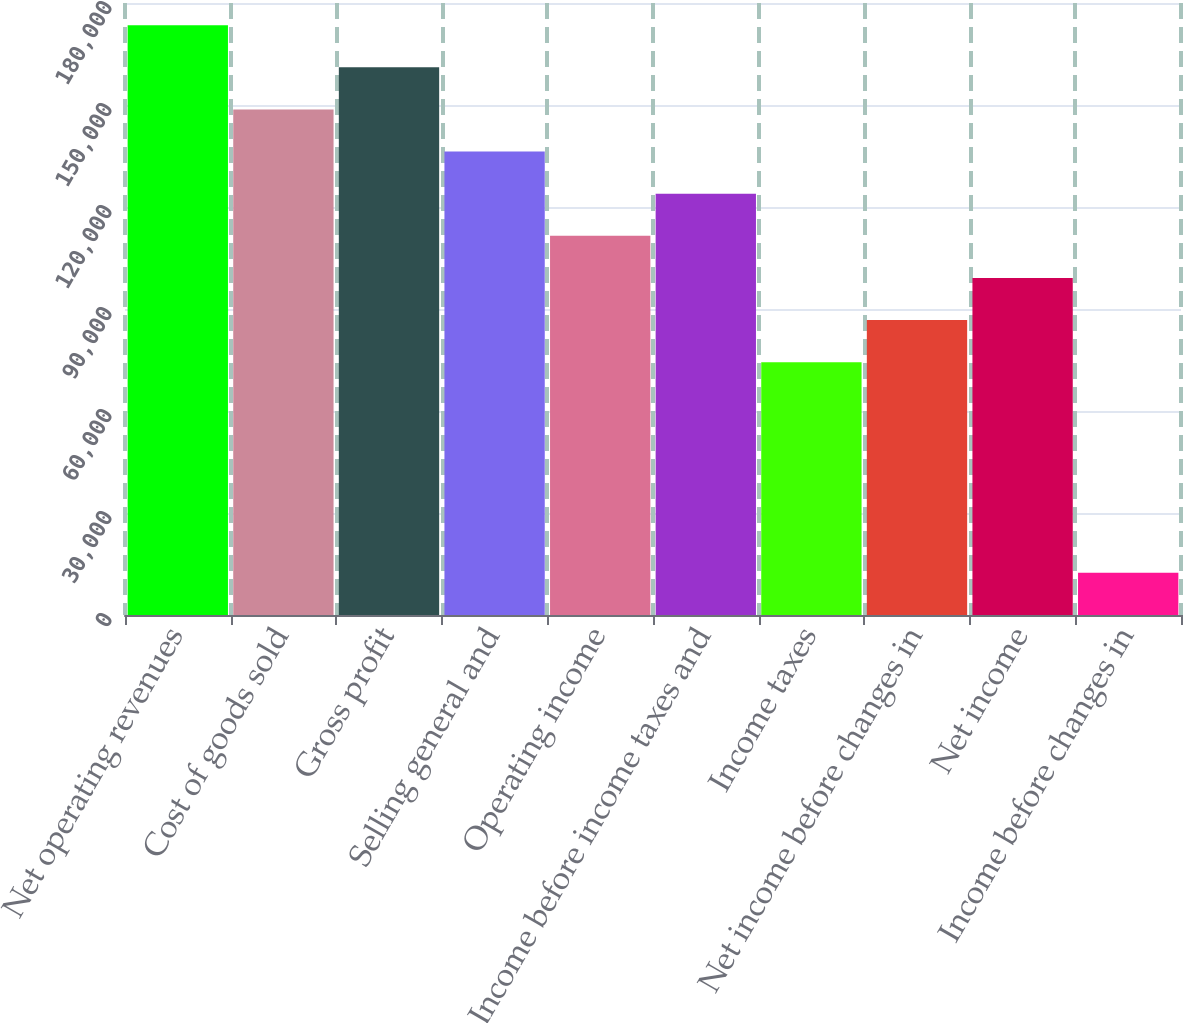<chart> <loc_0><loc_0><loc_500><loc_500><bar_chart><fcel>Net operating revenues<fcel>Cost of goods sold<fcel>Gross profit<fcel>Selling general and<fcel>Operating income<fcel>Income before income taxes and<fcel>Income taxes<fcel>Net income before changes in<fcel>Net income<fcel>Income before changes in<nl><fcel>173471<fcel>148689<fcel>161080<fcel>136299<fcel>111517<fcel>123908<fcel>74345.1<fcel>86735.9<fcel>99126.6<fcel>12391.6<nl></chart> 